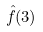<formula> <loc_0><loc_0><loc_500><loc_500>\hat { f } ( 3 )</formula> 